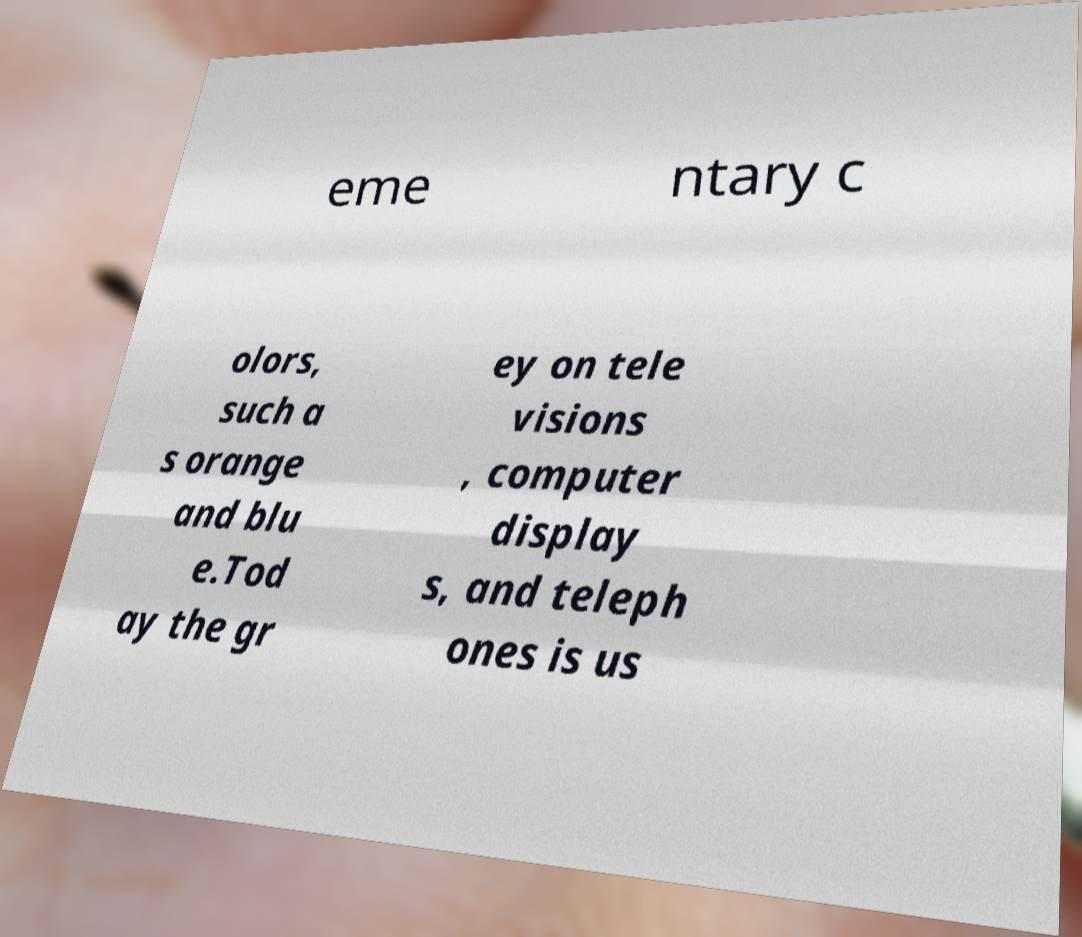Please read and relay the text visible in this image. What does it say? eme ntary c olors, such a s orange and blu e.Tod ay the gr ey on tele visions , computer display s, and teleph ones is us 